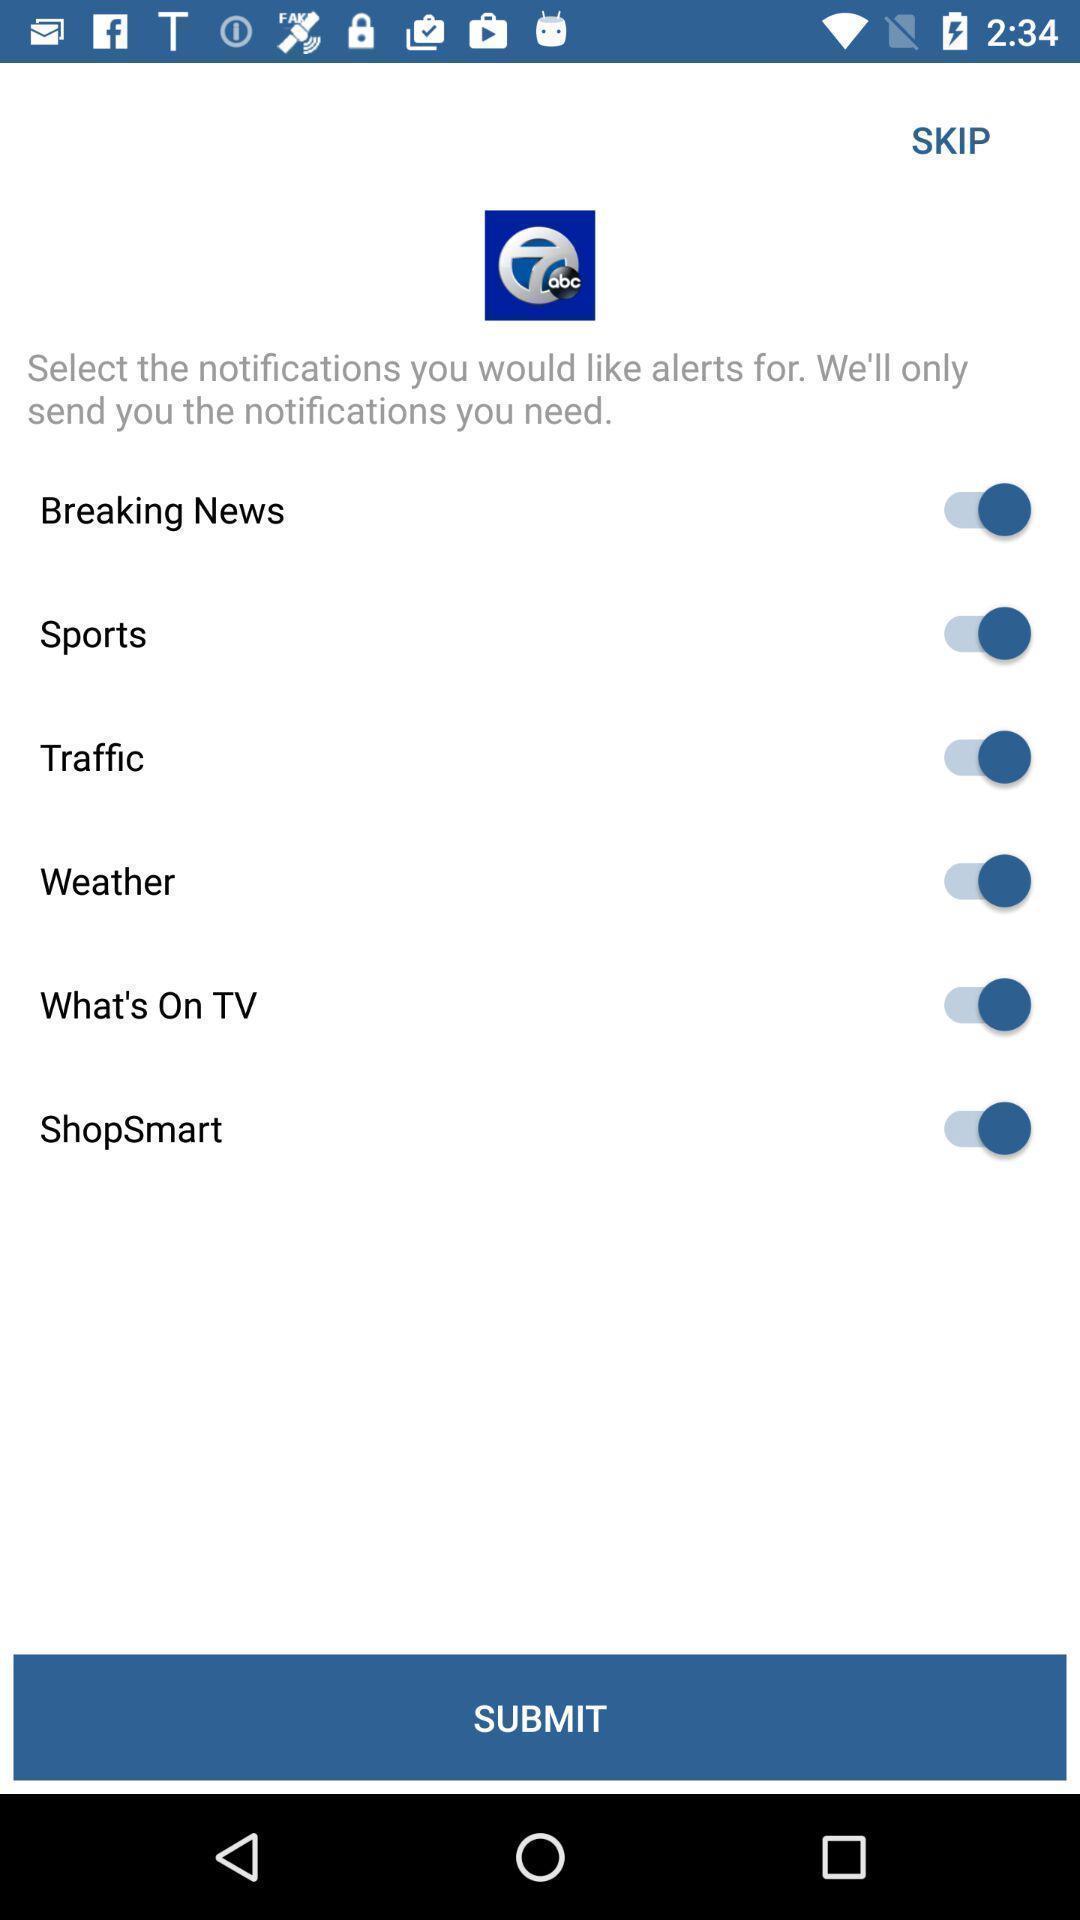Describe this image in words. Screen shows list of notification options in a news app. 